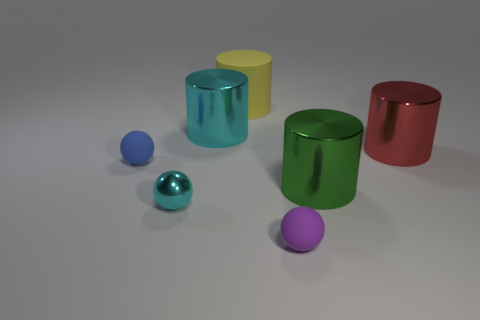The green thing that is the same material as the small cyan sphere is what shape?
Provide a short and direct response. Cylinder. What number of cyan things have the same shape as the purple object?
Provide a succinct answer. 1. What is the tiny cyan sphere made of?
Keep it short and to the point. Metal. Do the metal ball and the metallic cylinder to the left of the green metallic object have the same color?
Ensure brevity in your answer.  Yes. How many balls are either blue rubber things or cyan things?
Provide a succinct answer. 2. There is a tiny sphere to the right of the big cyan object; what color is it?
Your response must be concise. Purple. There is a large thing that is the same color as the small shiny object; what is its shape?
Make the answer very short. Cylinder. What number of green shiny objects have the same size as the blue sphere?
Keep it short and to the point. 0. There is a large rubber thing behind the big green object; is it the same shape as the big metallic object that is to the left of the large matte thing?
Ensure brevity in your answer.  Yes. There is a tiny thing that is left of the cyan metal sphere that is to the left of the metal cylinder behind the red shiny thing; what is it made of?
Ensure brevity in your answer.  Rubber. 